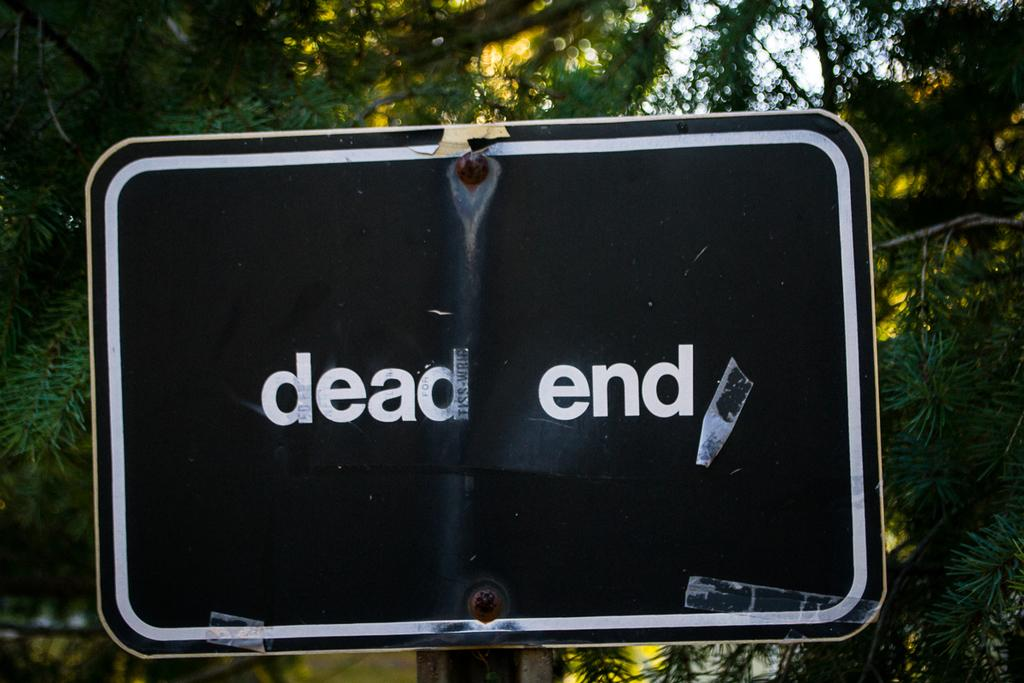What is the main object in the image? There is a board in the image. What is written on the board? The board has the words "dead end" written on it. What can be seen in the background of the image? There are trees visible behind the board. Can you see any cobwebs on the board in the image? There is no mention of cobwebs in the image, so it cannot be determined if any are present. 